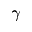<formula> <loc_0><loc_0><loc_500><loc_500>\gamma</formula> 